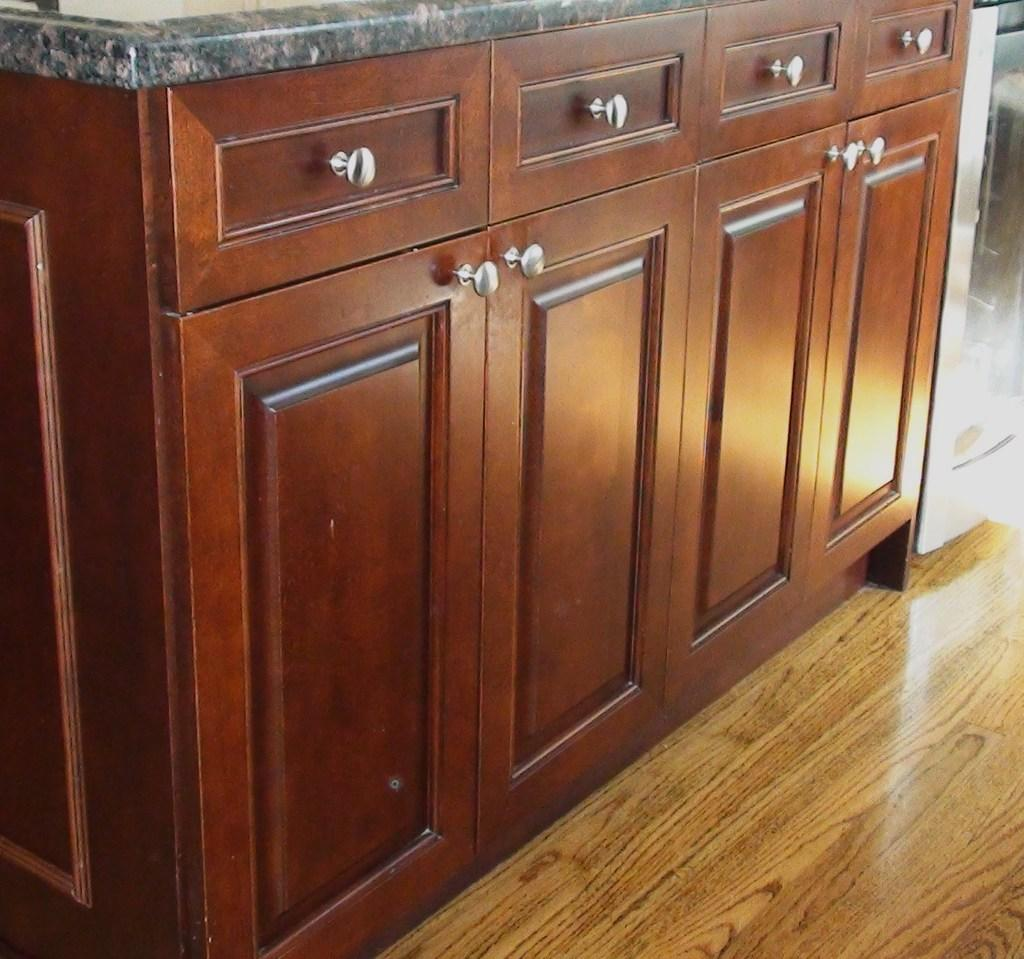What type of furniture is present in the image? There is a wooden cupboard in the image. How is the wooden cupboard positioned in the image? The wooden cupboard is arranged on the floor. What can be seen in the background of the image? There is an object in the background of the image. What type of paper is being used to form the wooden cupboard in the image? The wooden cupboard is not made of paper; it is made of wood. 